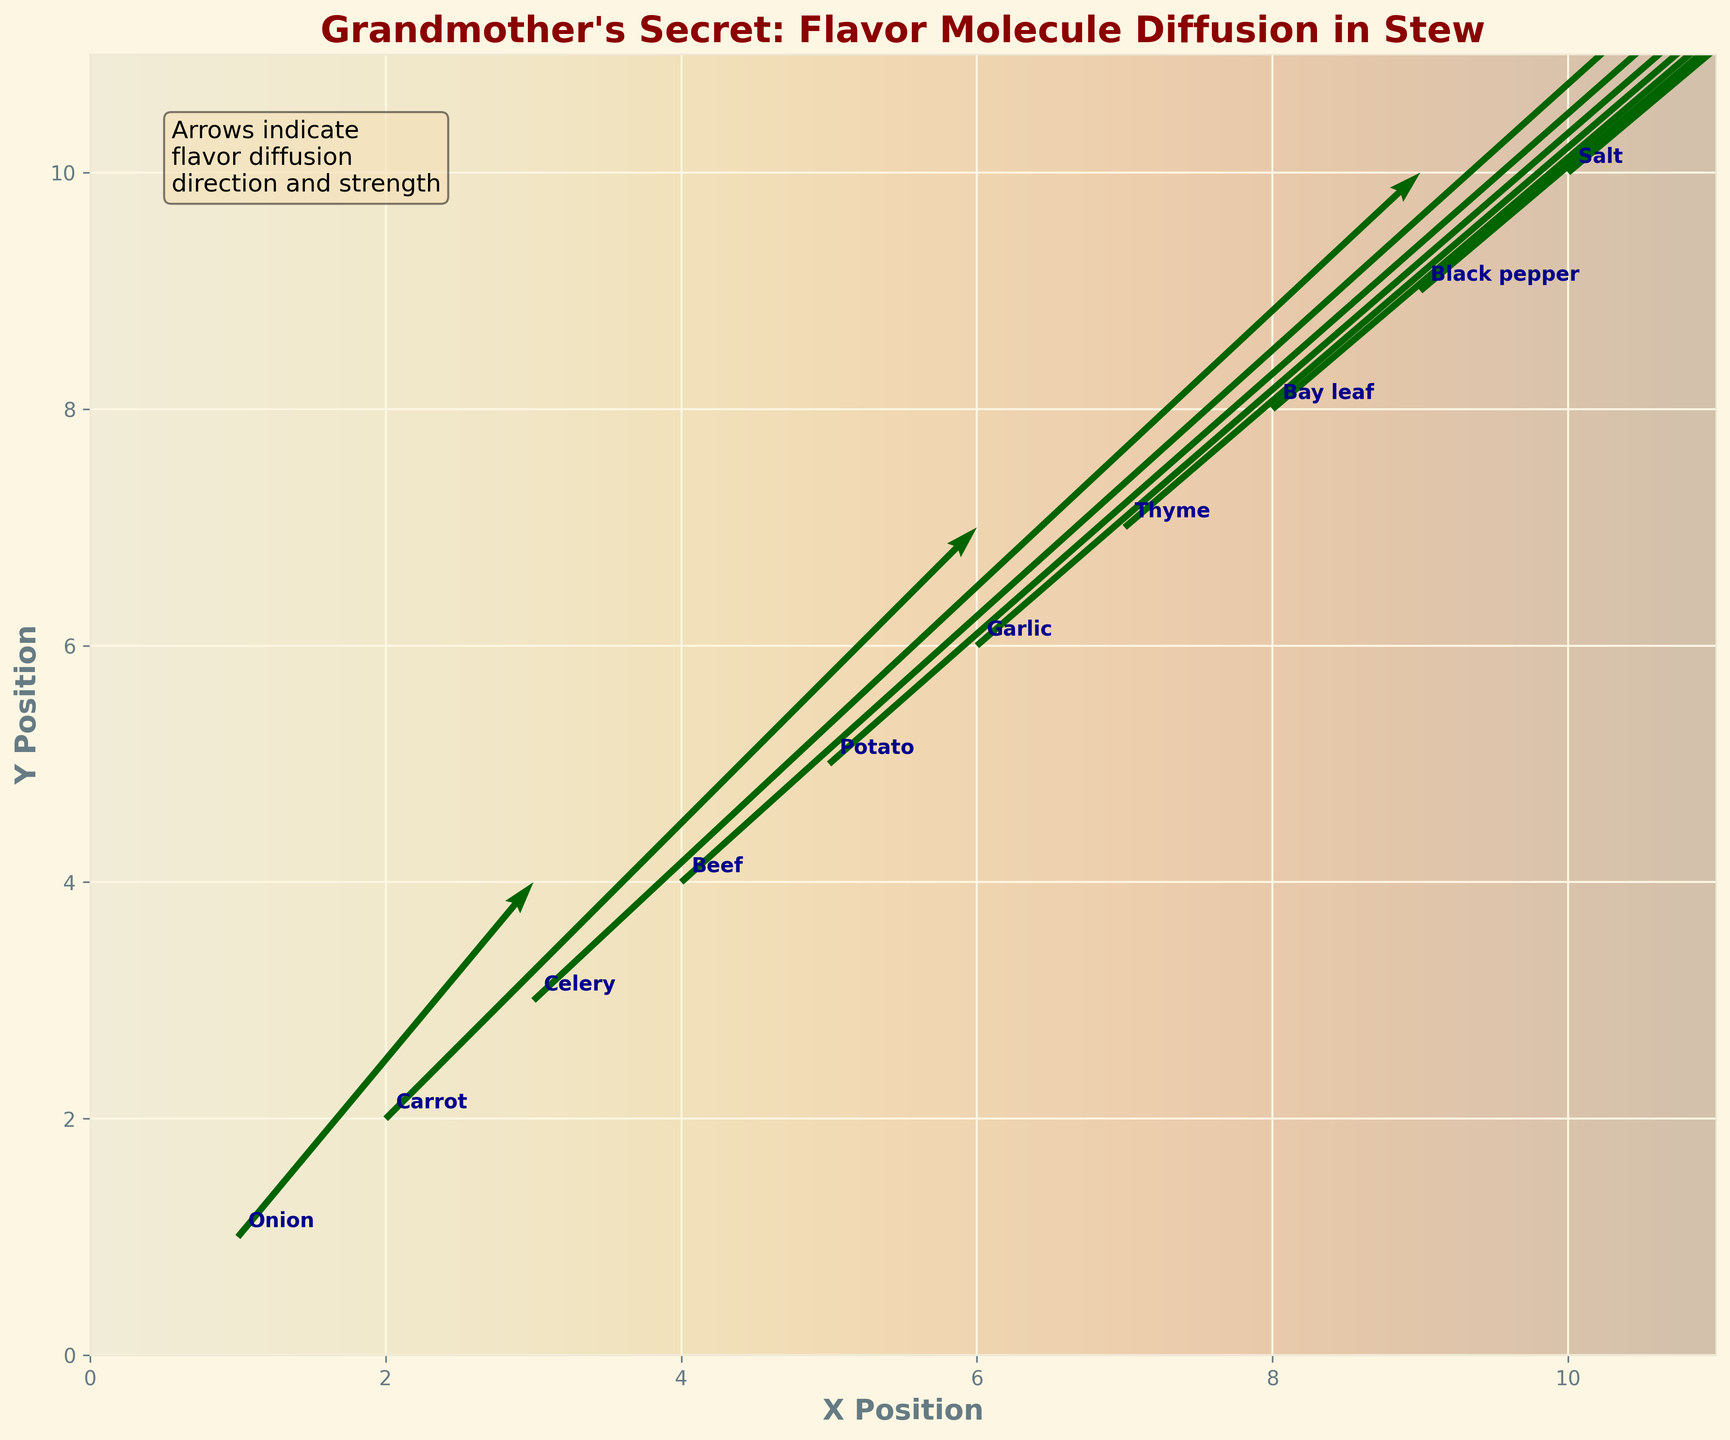What is the title of the quiver plot? The title is displayed at the top of the quiver plot, in bold and colored dark red, making it easy to identify.
Answer: Grandmother's Secret: Flavor Molecule Diffusion in Stew How many different ingredients are labeled in the plot? Each ingredient has been annotated on the plot with their corresponding positions, which total 10 different points.
Answer: 10 Which ingredient shows the highest diffusion rate in both X and Y directions combined? The diffusion rate in both directions is indicated by the length of the arrows. By comparing the values, we find the sum of the diffusion rates (u+v) and identify the highest.
Answer: Salt How does the diffusion strength of Onion compare to that of Garlic? Onion has diffusion vectors of (0.2, 0.3), while Garlic has (1.2, 1.3). By comparing these vectors, we see that Garlic has higher diffusion strength.
Answer: Garlic has a higher diffusion strength than Onion Which ingredient has its diffusion vector pointing from (1,1) to (1.2, 1.3)? The quiver vectors indicate the direction of flavor diffusion. For (1,1) to (1.2,1.3), we need the corresponding u and v values. Onion's diffusion (0.2, 0.3) results in this vector.
Answer: Onion What is the direction of the diffusion vector for Thyme? The direction is indicated by the arrow originating from Thyme's position and extending in the direction of its u and v values.
Answer: Roughly northwest Between Carrot and Bay leaf, which ingredient has a stronger diffusion strength in the Y direction? Carrot's Y diffusion is 0.5, whereas Bay leaf's Y diffusion is 1.7. Comparing these, Bay leaf has a stronger Y diffusion.
Answer: Bay leaf What is the average X position of all the ingredients shown? The X positions (1 to 10) of each ingredient are summed and then divided by the number of ingredients to get the average. (1+2+3+4+5+6+7+8+9+10)/10 = 5.5
Answer: 5.5 For which ingredient does the diffusion arrow point directly diagonal (45 degrees)? Diagonal diffusion implies equal rates in both X and Y directions (u = v). Checking the data, Salt's diffusion vector (2.0, 2.1) approximates this diagonal direction due to close values of u and v.
Answer: Salt How far does the diffusion vector for Black pepper extend from its starting point? The diffusion distance can be calculated using the Pythagorean theorem for the vector components (u=1.8, v=1.9), giving √(1.8² + 1.9²) ≈ 2.61.
Answer: Approximately 2.61 units 